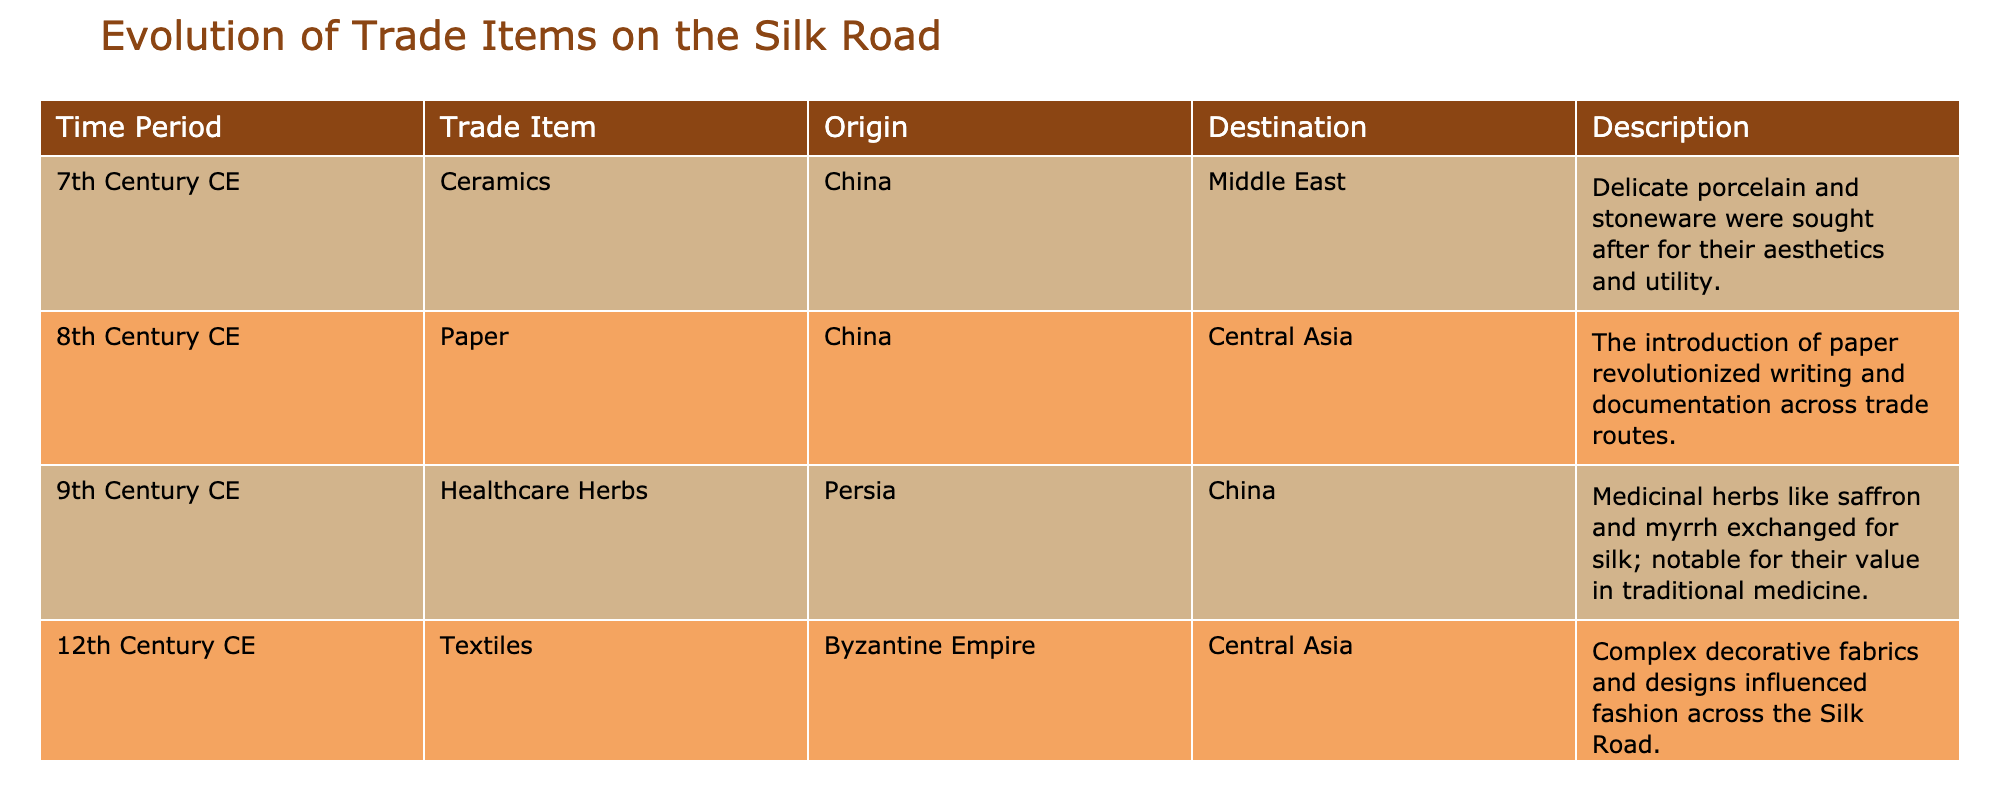What trade item was introduced in the 8th century CE? The table indicates that paper is the trade item introduced in the 8th century CE, as listed under that time period.
Answer: Paper From which origin did healthcare herbs originate in the 9th century CE? According to the table, healthcare herbs in the 9th century CE originated from Persia, as stated in the "Origin" column for that row.
Answer: Persia Which trade item was exchanged for silk in the 9th century CE? The table specifies that healthcare herbs, such as saffron and myrrh, were exchanged for silk, as indicated in the "Description" for that time period.
Answer: Healthcare Herbs Which time period saw the exchange of textiles from the Byzantine Empire? The table presents that textiles from the Byzantine Empire were exchanged in the 12th century CE, as indicated under that time period.
Answer: 12th Century CE How many trade items are listed in the table? There are four trade items listed in the table, one for each of the four time periods presented. Counting them gives: Ceramics, Paper, Healthcare Herbs, and Textiles.
Answer: 4 Was paper used for writing before the 8th century CE according to the table? The table indicates that the introduction of paper occurred in the 8th century CE, suggesting it was not available before that time for writing.
Answer: No What is the destination for ceramics traded in the 7th century CE? The table shows that the destination for ceramics traded in the 7th century CE was the Middle East, as noted in the "Destination" column for that row.
Answer: Middle East Which item has its destination listed as Central Asia and in which century? In the table, textiles are listed as going to Central Asia in the 12th century CE, as indicated in the respective row under "Destination" and "Time Period."
Answer: Textiles, 12th Century CE What are the two origins mentioned in the table and which item do they correspond to? The origins mentioned are China and Persia. China corresponds with ceramics and paper, while Persia corresponds with healthcare herbs.
Answer: China (Ceramics, Paper), Persia (Healthcare Herbs) What is the main significance of paper according to its description? The description states that paper revolutionized writing and documentation across trade routes, emphasizing its importance in communication and record-keeping.
Answer: Revolutionized writing and documentation 